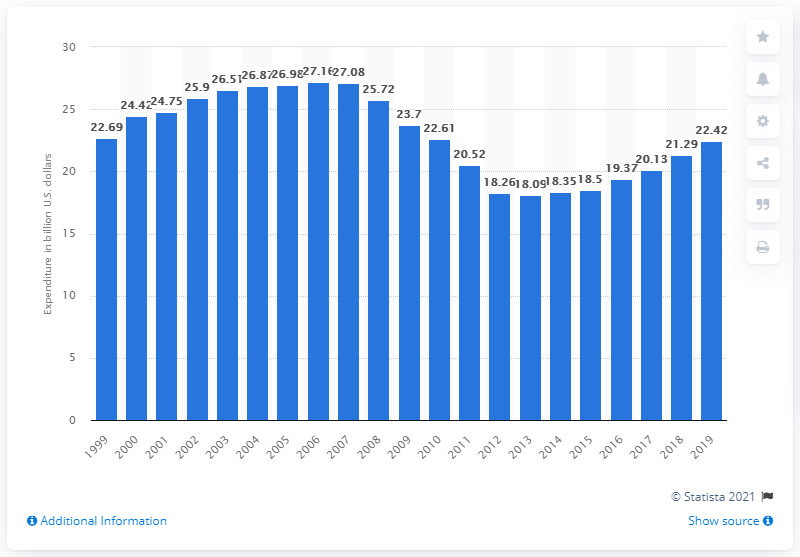What information is missing from this bar chart that would provide a more comprehensive understanding of recreational book spending habits? The chart does not include data on the types of recreational books purchased, demographic information of consumers, digital versus physical book sales, or the influence of major events or technological changes on spending habits. Additionally, figures adjusted for inflation would offer more insights into real spending power changes over the years. 